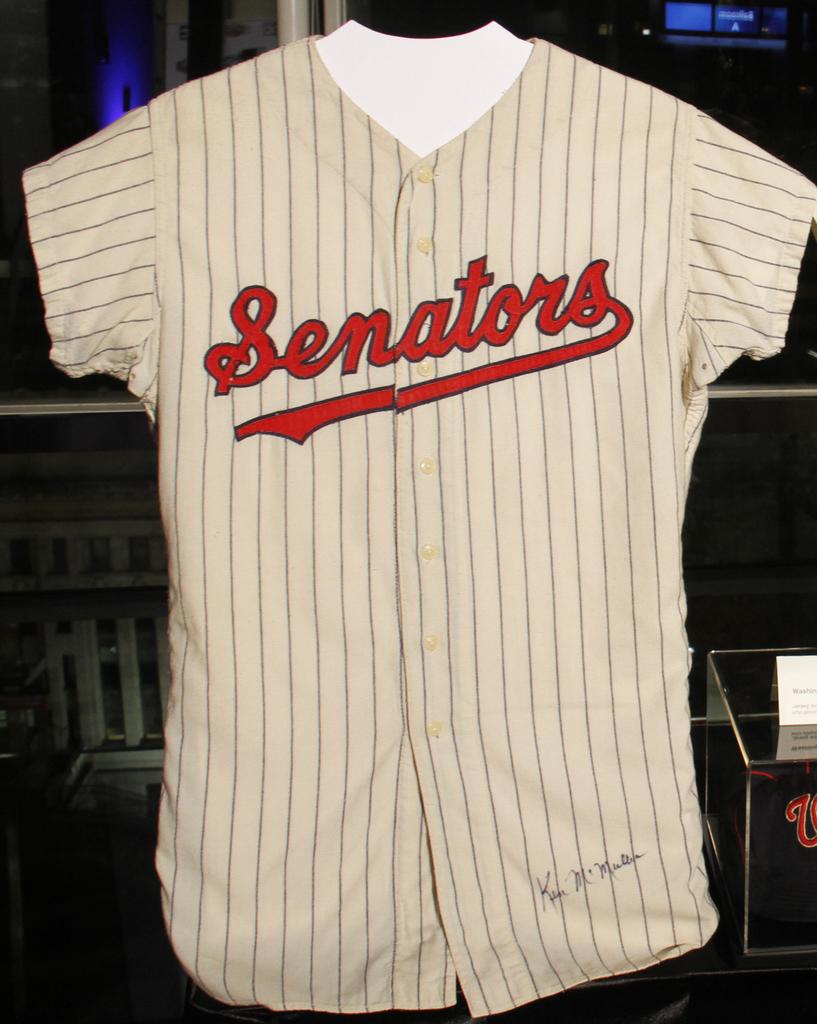What team is the owner of the jersey?
Your answer should be very brief. Senators. 